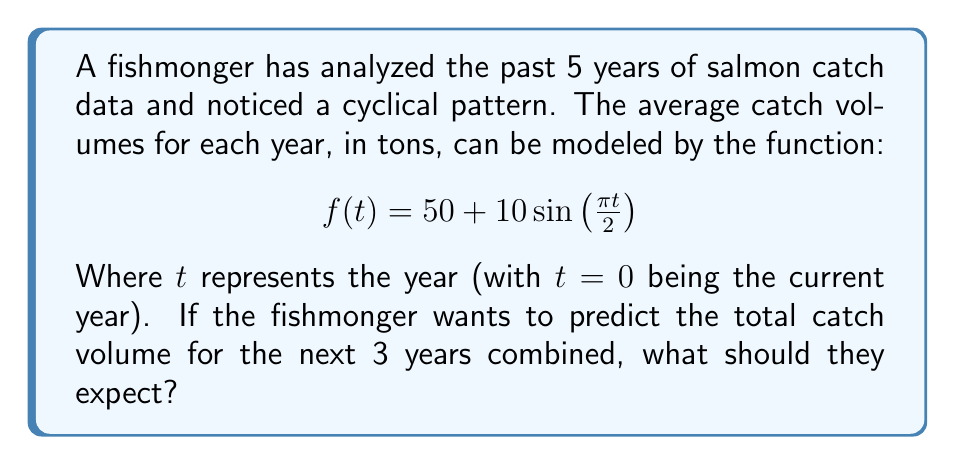Help me with this question. To solve this problem, we need to follow these steps:

1. Understand the given function:
   $$f(t) = 50 + 10\sin(\frac{\pi t}{2})$$
   This function represents the average catch volume in tons for each year.

2. Calculate the catch volume for the next 3 years:
   - For year 1: $t = 1$
   - For year 2: $t = 2$
   - For year 3: $t = 3$

3. Evaluate the function for each year:
   
   Year 1 ($t = 1$):
   $$f(1) = 50 + 10\sin(\frac{\pi}{2}) = 50 + 10 = 60\text{ tons}$$

   Year 2 ($t = 2$):
   $$f(2) = 50 + 10\sin(\pi) = 50 + 0 = 50\text{ tons}$$

   Year 3 ($t = 3$):
   $$f(3) = 50 + 10\sin(\frac{3\pi}{2}) = 50 - 10 = 40\text{ tons}$$

4. Sum up the catch volumes for all three years:
   $$\text{Total} = 60 + 50 + 40 = 150\text{ tons}$$

Therefore, the fishmonger should expect a total catch volume of 150 tons for the next 3 years combined.
Answer: 150 tons 